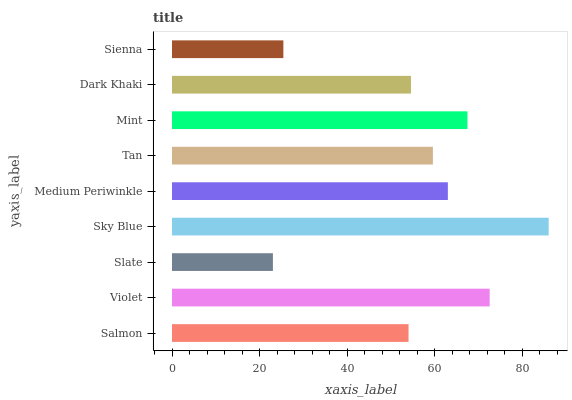Is Slate the minimum?
Answer yes or no. Yes. Is Sky Blue the maximum?
Answer yes or no. Yes. Is Violet the minimum?
Answer yes or no. No. Is Violet the maximum?
Answer yes or no. No. Is Violet greater than Salmon?
Answer yes or no. Yes. Is Salmon less than Violet?
Answer yes or no. Yes. Is Salmon greater than Violet?
Answer yes or no. No. Is Violet less than Salmon?
Answer yes or no. No. Is Tan the high median?
Answer yes or no. Yes. Is Tan the low median?
Answer yes or no. Yes. Is Sienna the high median?
Answer yes or no. No. Is Slate the low median?
Answer yes or no. No. 